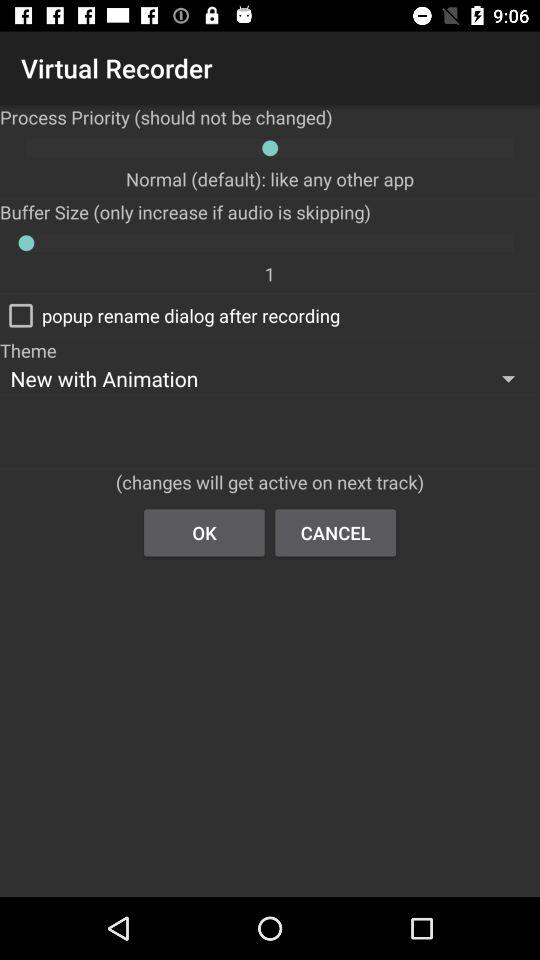What is the theme name? The theme name is "New with Animation". 